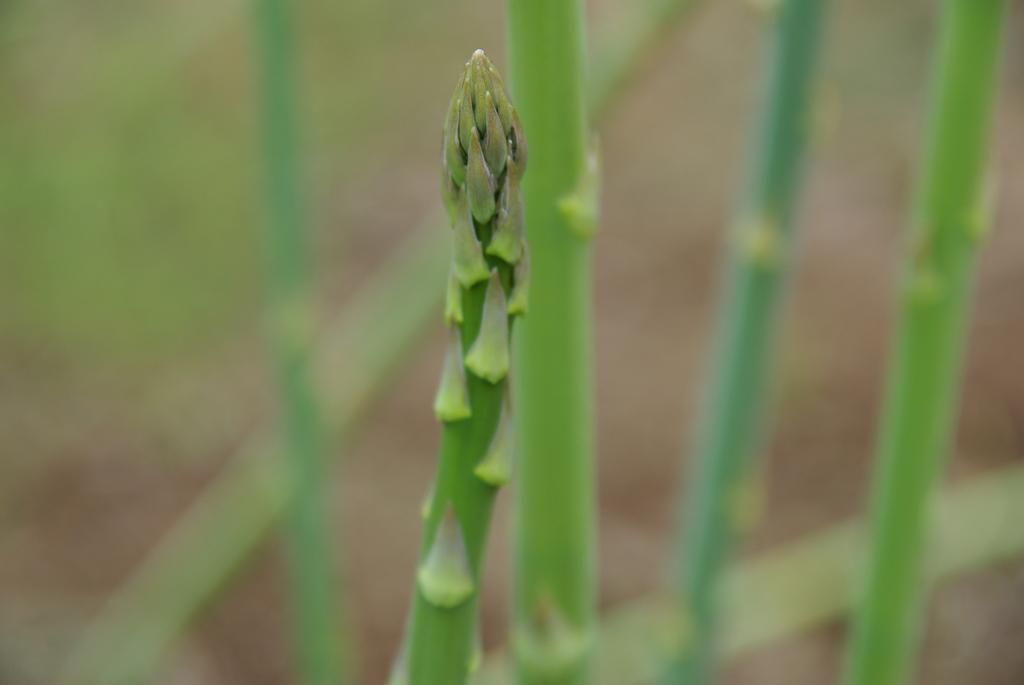What type of living organisms can be seen in the image? Plants can be seen in the image. Can you describe the background of the image? The background of the image is blurry. What type of net is being used by the doctor in the image? There is no doctor or net present in the image; it only features plants and a blurry background. 